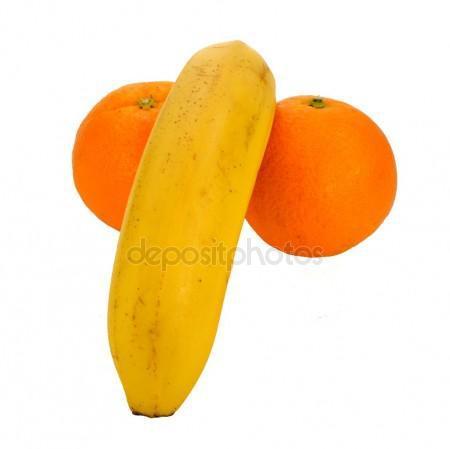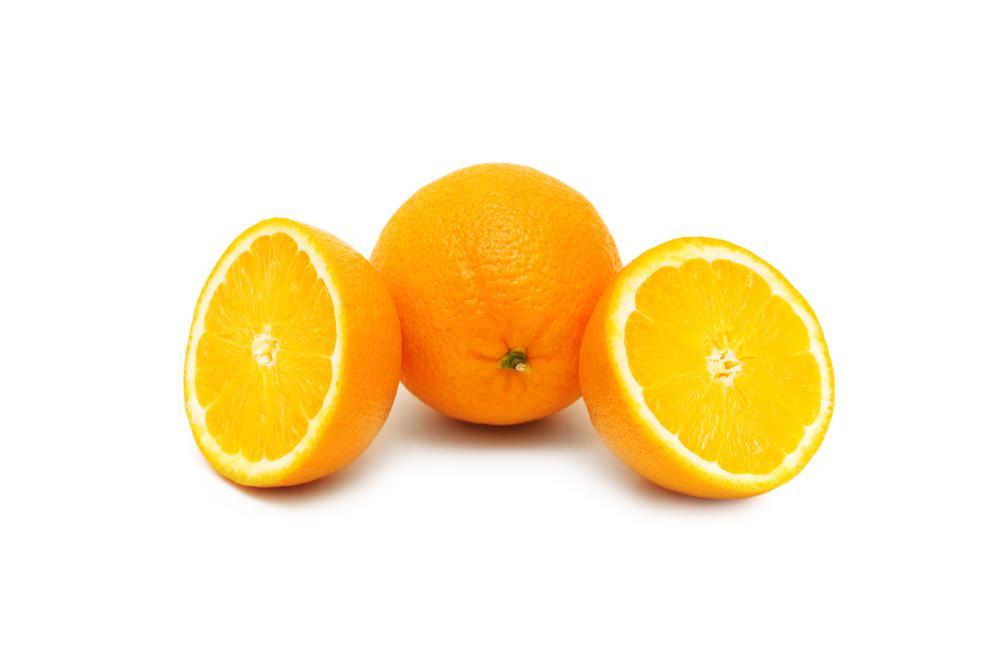The first image is the image on the left, the second image is the image on the right. For the images displayed, is the sentence "One of the images has exactly two uncut oranges without any other fruits present." factually correct? Answer yes or no. No. The first image is the image on the left, the second image is the image on the right. For the images shown, is this caption "There is at least six oranges that are not cut in any way." true? Answer yes or no. No. 